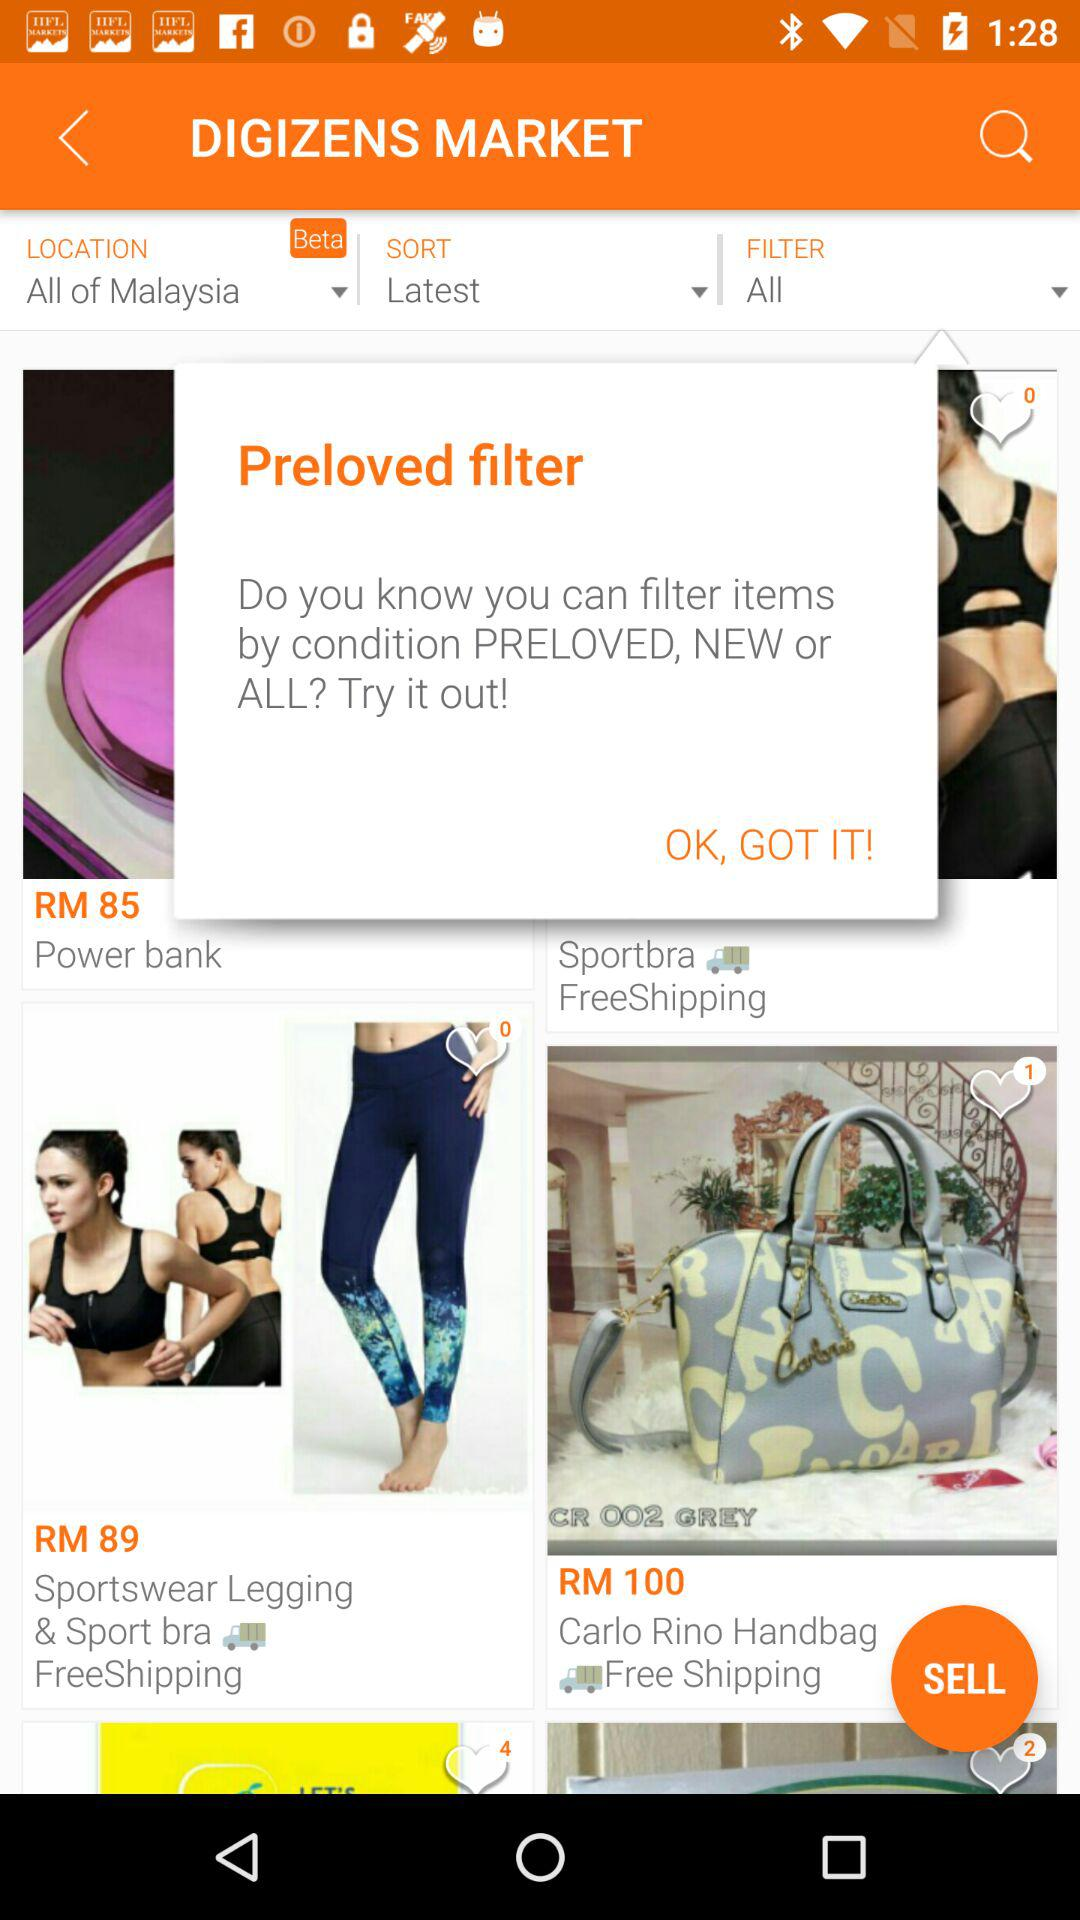What is the price of the power bank? The price of the power bank is RM 85. 